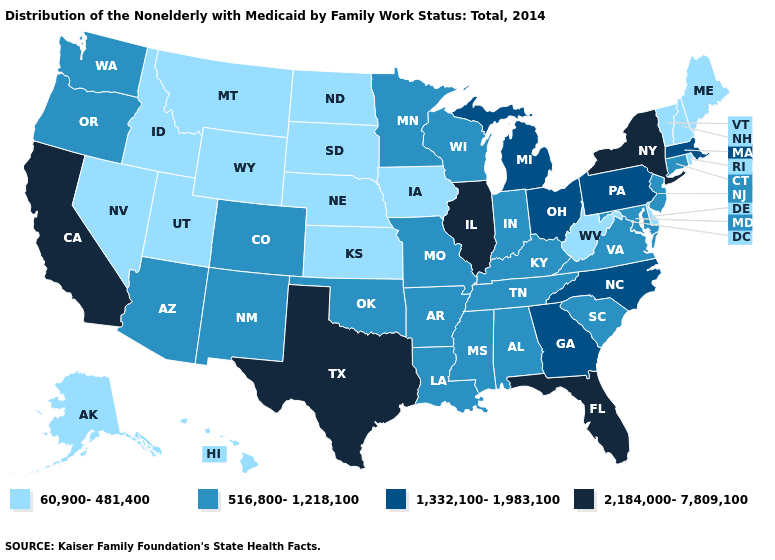Which states have the highest value in the USA?
Answer briefly. California, Florida, Illinois, New York, Texas. What is the highest value in states that border Wyoming?
Write a very short answer. 516,800-1,218,100. What is the value of North Dakota?
Concise answer only. 60,900-481,400. Does California have the highest value in the West?
Quick response, please. Yes. Among the states that border Alabama , which have the highest value?
Give a very brief answer. Florida. Name the states that have a value in the range 516,800-1,218,100?
Short answer required. Alabama, Arizona, Arkansas, Colorado, Connecticut, Indiana, Kentucky, Louisiana, Maryland, Minnesota, Mississippi, Missouri, New Jersey, New Mexico, Oklahoma, Oregon, South Carolina, Tennessee, Virginia, Washington, Wisconsin. Name the states that have a value in the range 60,900-481,400?
Write a very short answer. Alaska, Delaware, Hawaii, Idaho, Iowa, Kansas, Maine, Montana, Nebraska, Nevada, New Hampshire, North Dakota, Rhode Island, South Dakota, Utah, Vermont, West Virginia, Wyoming. Which states have the highest value in the USA?
Give a very brief answer. California, Florida, Illinois, New York, Texas. Name the states that have a value in the range 1,332,100-1,983,100?
Quick response, please. Georgia, Massachusetts, Michigan, North Carolina, Ohio, Pennsylvania. What is the value of Oregon?
Give a very brief answer. 516,800-1,218,100. Name the states that have a value in the range 2,184,000-7,809,100?
Be succinct. California, Florida, Illinois, New York, Texas. Does Wyoming have a lower value than Oklahoma?
Be succinct. Yes. What is the highest value in the USA?
Short answer required. 2,184,000-7,809,100. What is the lowest value in the USA?
Write a very short answer. 60,900-481,400. What is the lowest value in the USA?
Answer briefly. 60,900-481,400. 